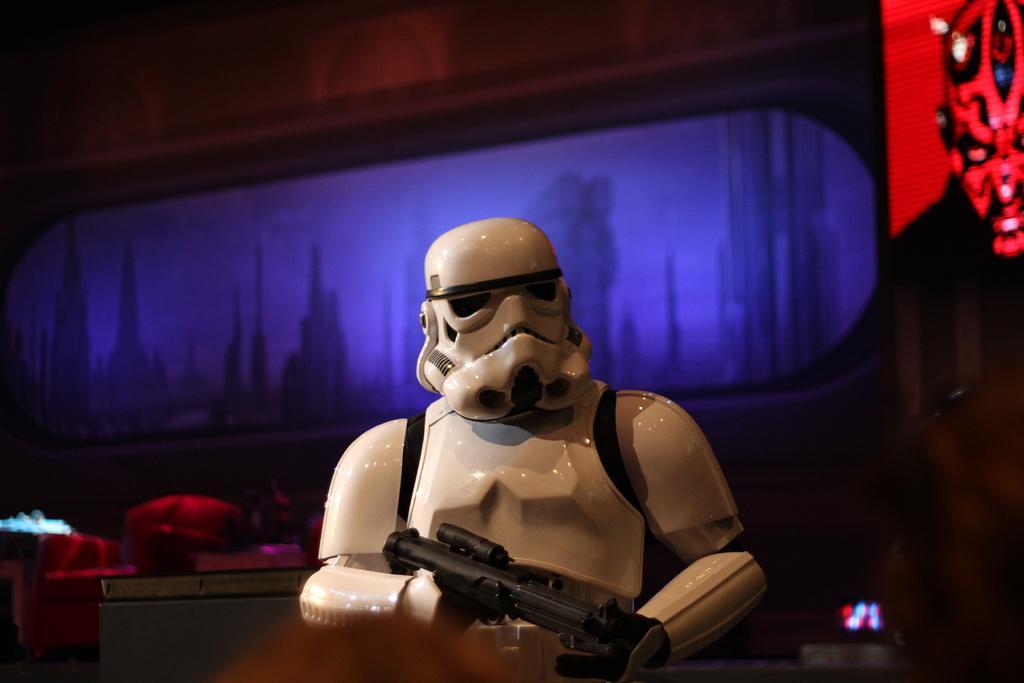How would you summarize this image in a sentence or two? In this image there is a robot holding a gun, there is a screen behind the robot. 